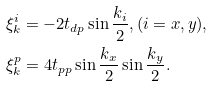<formula> <loc_0><loc_0><loc_500><loc_500>& \xi ^ { i } _ { k } = - 2 t _ { d p } \sin \frac { k _ { i } } { 2 } , ( i = x , y ) , \\ & \xi ^ { p } _ { k } = 4 t _ { p p } \sin \frac { k _ { x } } { 2 } \sin \frac { k _ { y } } { 2 } .</formula> 